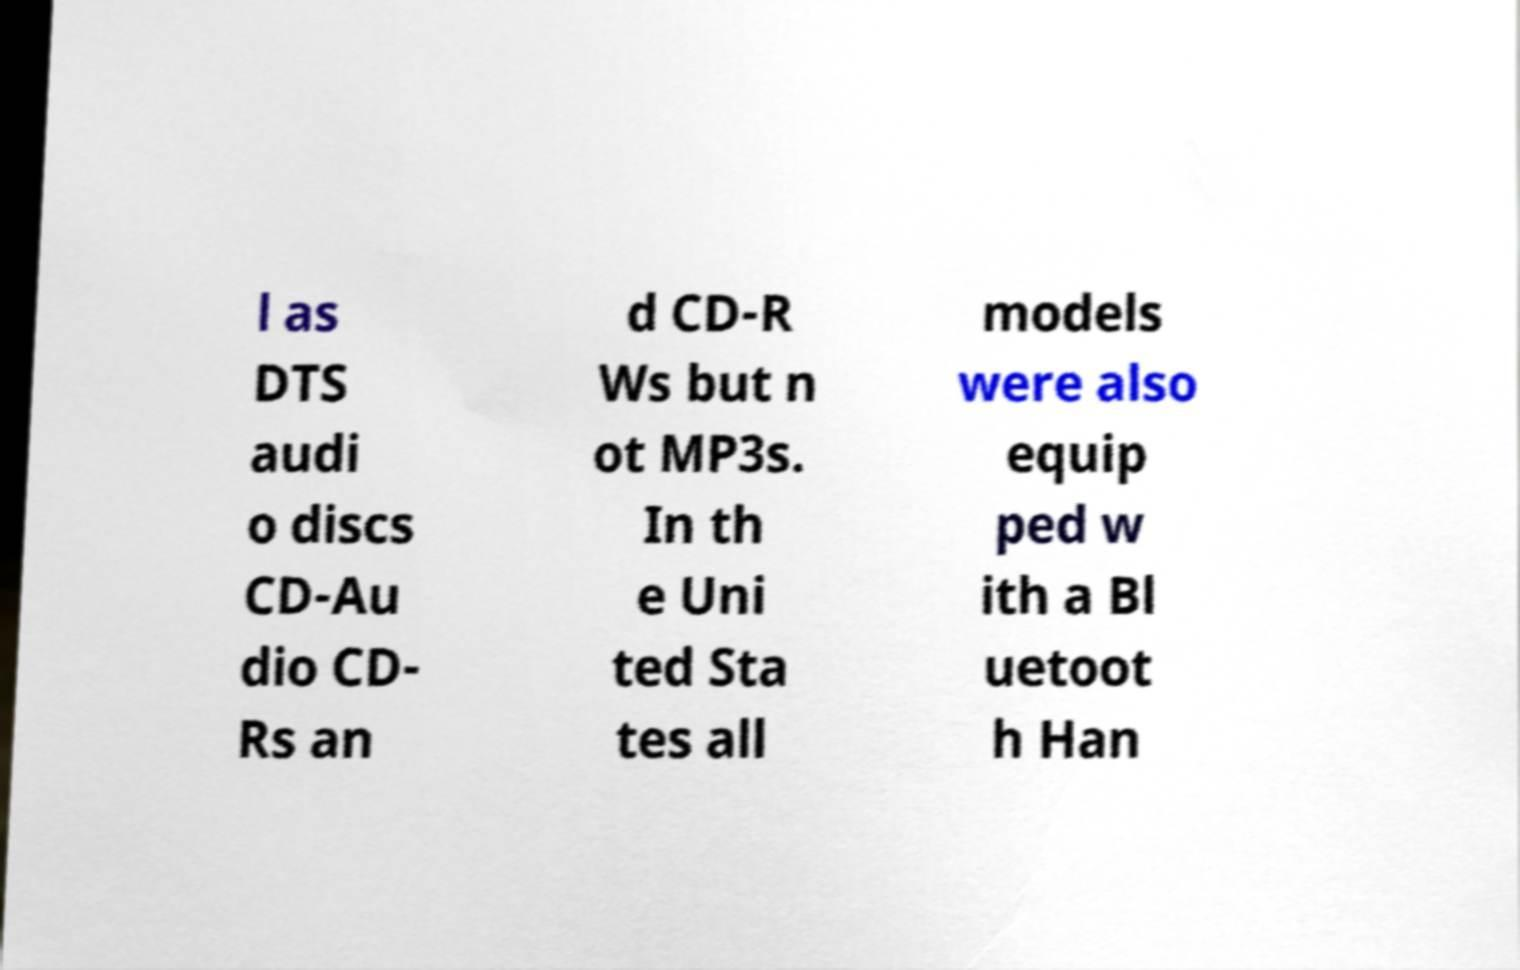Can you accurately transcribe the text from the provided image for me? l as DTS audi o discs CD-Au dio CD- Rs an d CD-R Ws but n ot MP3s. In th e Uni ted Sta tes all models were also equip ped w ith a Bl uetoot h Han 